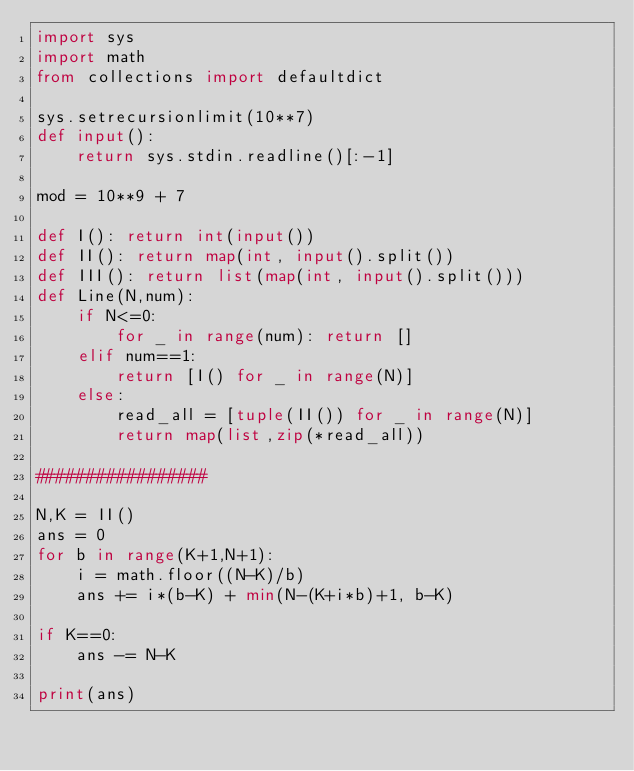<code> <loc_0><loc_0><loc_500><loc_500><_Python_>import sys
import math
from collections import defaultdict

sys.setrecursionlimit(10**7)
def input():
    return sys.stdin.readline()[:-1]

mod = 10**9 + 7

def I(): return int(input())
def II(): return map(int, input().split())
def III(): return list(map(int, input().split()))
def Line(N,num):
    if N<=0:
        for _ in range(num): return []
    elif num==1:
        return [I() for _ in range(N)]
    else:
        read_all = [tuple(II()) for _ in range(N)]
        return map(list,zip(*read_all))

#################

N,K = II()
ans = 0
for b in range(K+1,N+1):
    i = math.floor((N-K)/b)
    ans += i*(b-K) + min(N-(K+i*b)+1, b-K)

if K==0:
    ans -= N-K

print(ans)</code> 